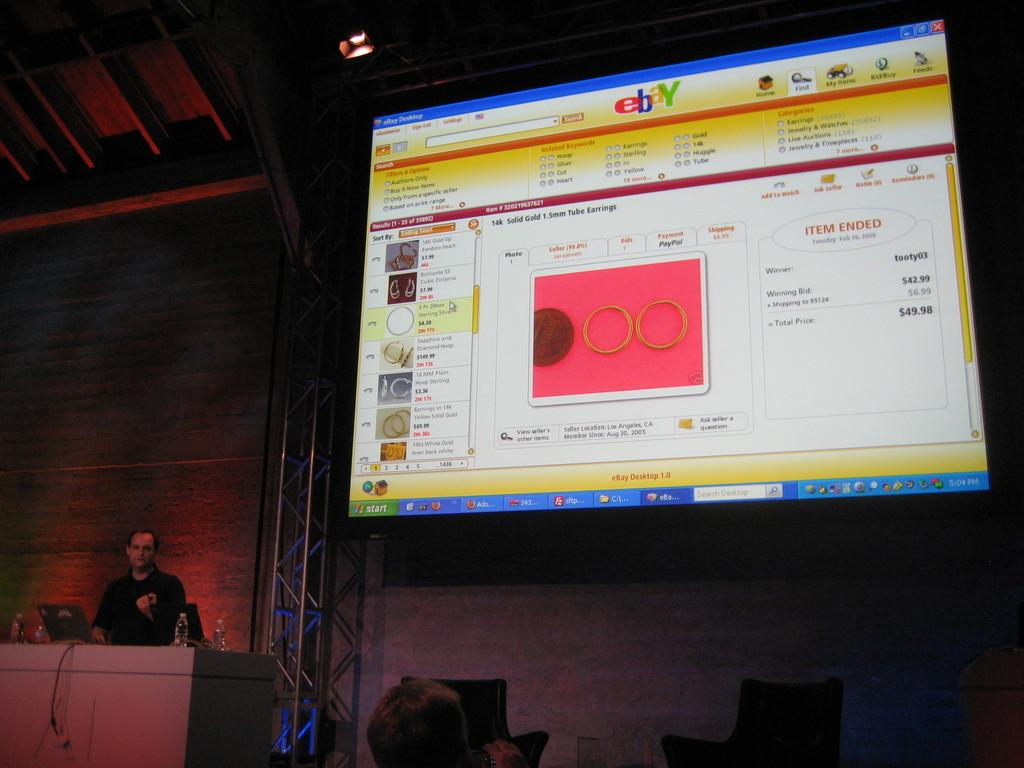<image>
Provide a brief description of the given image. On a giant screen is a website for ebay. 